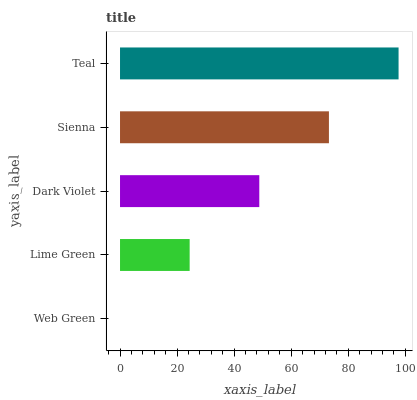Is Web Green the minimum?
Answer yes or no. Yes. Is Teal the maximum?
Answer yes or no. Yes. Is Lime Green the minimum?
Answer yes or no. No. Is Lime Green the maximum?
Answer yes or no. No. Is Lime Green greater than Web Green?
Answer yes or no. Yes. Is Web Green less than Lime Green?
Answer yes or no. Yes. Is Web Green greater than Lime Green?
Answer yes or no. No. Is Lime Green less than Web Green?
Answer yes or no. No. Is Dark Violet the high median?
Answer yes or no. Yes. Is Dark Violet the low median?
Answer yes or no. Yes. Is Sienna the high median?
Answer yes or no. No. Is Teal the low median?
Answer yes or no. No. 